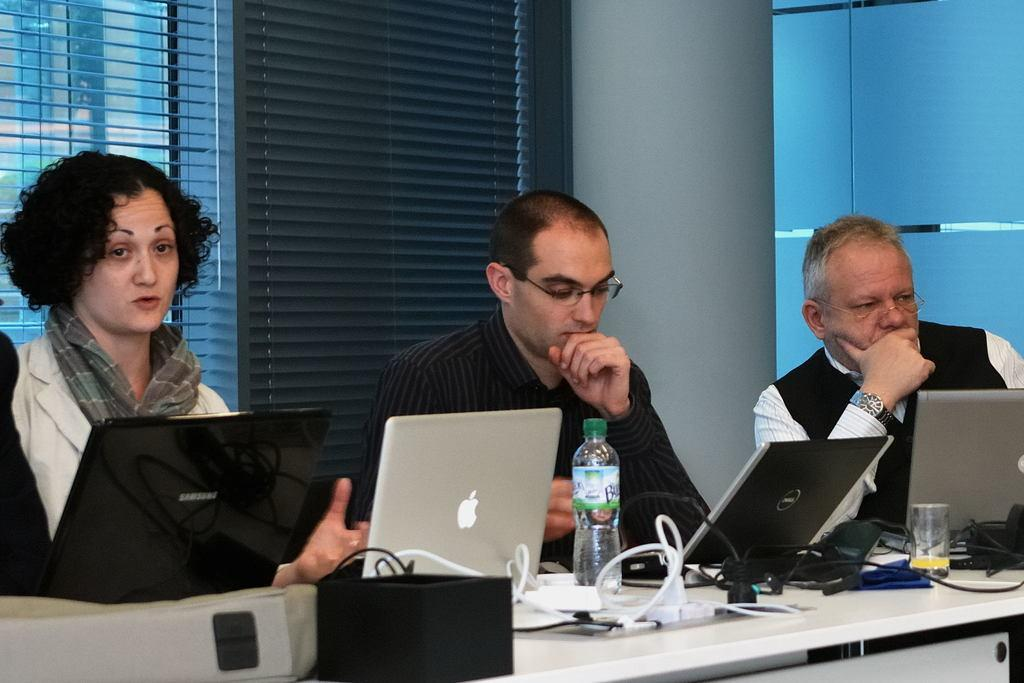How many people are in the image? There are three people in the image: one woman and two men. What are the individuals doing in the image? The individuals are sitting. What objects are in front of them? There are laptops, a bottle, a glass, and wires in front of them. What can be seen at the back of the individuals? There are windows with curtains and a wall visible at the back of the individuals. What type of button is being used to control the stage in the image? There is no stage or button present in the image. What is the significance of the quince in the image? There is no quince present in the image. 